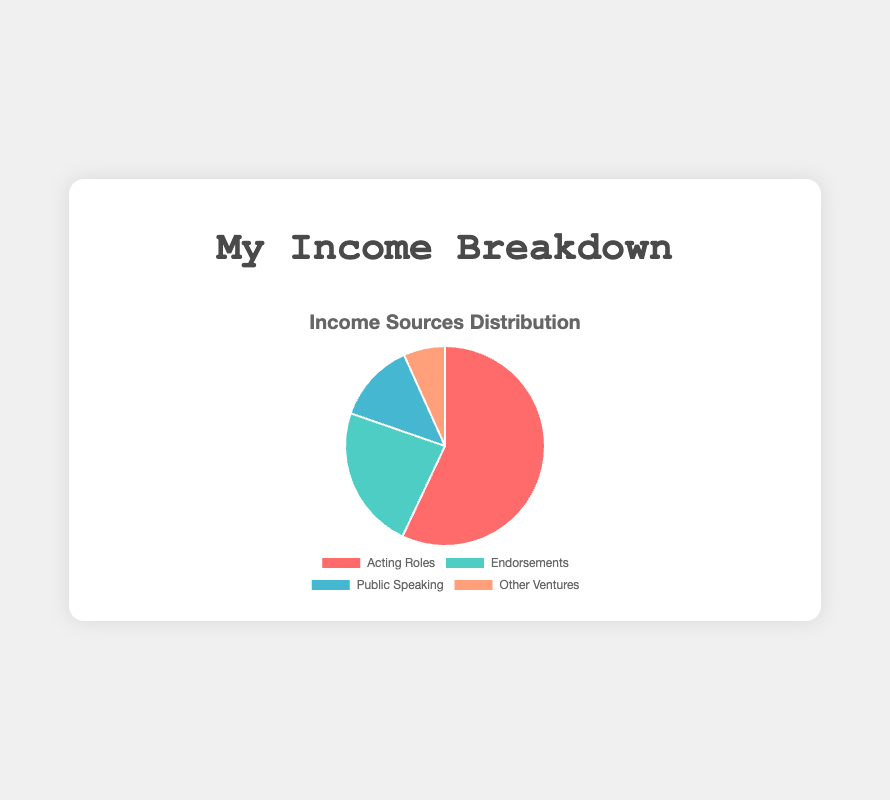What percentage of my total income comes from Acting Roles? To find the percentage, sum up the income from Acting Roles (60,000 + 35,000 + 15,000 = 110,000). Then, sum up the total income from all sources. The total income across all sources is 153,000. The percentage is (110,000 / 153,000) * 100, which is approximately 71.9%.
Answer: 71.9% Which source contributes the least to my total income? By visually comparing the slices of the pie chart, we see that "Other Ventures" has the smallest slice.
Answer: Other Ventures How much more income do Endorsements generate compared to Public Speaking? Using the chart data, add the incomes from Endorsements (20,000 + 25,000 = 45,000) and from Public Speaking (10,000 + 15,000 = 25,000), then subtract the latter from the former (45,000 - 25,000 = 20,000).
Answer: 20,000 What is the combined income from Feature Film and Television Series projects? Add the incomes from Feature Film (60,000) and Television Series (35,000). 60,000 + 35,000 = 95,000.
Answer: 95,000 Which source has the largest slice in the pie chart, and what is its income? By looking at the pie chart, "Acting Roles" has the largest slice. The combined income for Acting Roles is 110,000.
Answer: Acting Roles, 110,000 What is the income difference between the largest and smallest income sources? Identify the largest (Acting Roles: 110,000) and smallest (Other Ventures: 13,000) income sources from the chart. Subtract the smallest from the largest (110,000 - 13,000 = 97,000).
Answer: 97,000 How does Commercial income compare to the income from Book Royalties and YouTube Channel combined? Compare the income from Commercials (15,000) to the combined income from Book Royalties (5,000) and YouTube Channel (8,000). The combined income is 5,000 + 8,000 = 13,000, which is less than 15,000.
Answer: Commercial income > Book Royalties + YouTube Channel What percentage of income is generated by each endorsement brand? Calculate the percentage for each brand. For FitLife Supplements: (20,000 / 153,000) * 100 ≈ 13.1%. For EcoWear Clothing: (25,000 / 153,000) * 100 ≈ 16.3%.
Answer: FitLife Supplements: 13.1%, EcoWear Clothing: 16.3% 